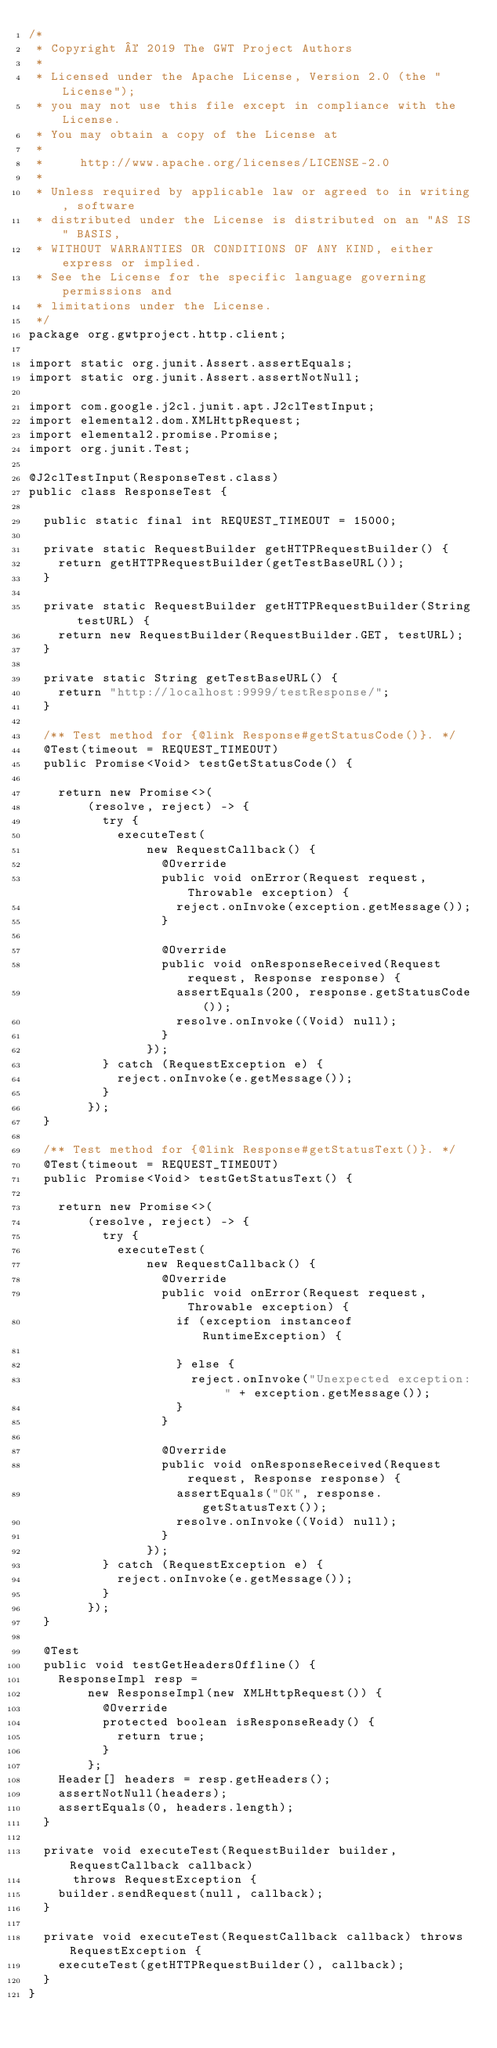<code> <loc_0><loc_0><loc_500><loc_500><_Java_>/*
 * Copyright © 2019 The GWT Project Authors
 *
 * Licensed under the Apache License, Version 2.0 (the "License");
 * you may not use this file except in compliance with the License.
 * You may obtain a copy of the License at
 *
 *     http://www.apache.org/licenses/LICENSE-2.0
 *
 * Unless required by applicable law or agreed to in writing, software
 * distributed under the License is distributed on an "AS IS" BASIS,
 * WITHOUT WARRANTIES OR CONDITIONS OF ANY KIND, either express or implied.
 * See the License for the specific language governing permissions and
 * limitations under the License.
 */
package org.gwtproject.http.client;

import static org.junit.Assert.assertEquals;
import static org.junit.Assert.assertNotNull;

import com.google.j2cl.junit.apt.J2clTestInput;
import elemental2.dom.XMLHttpRequest;
import elemental2.promise.Promise;
import org.junit.Test;

@J2clTestInput(ResponseTest.class)
public class ResponseTest {

  public static final int REQUEST_TIMEOUT = 15000;

  private static RequestBuilder getHTTPRequestBuilder() {
    return getHTTPRequestBuilder(getTestBaseURL());
  }

  private static RequestBuilder getHTTPRequestBuilder(String testURL) {
    return new RequestBuilder(RequestBuilder.GET, testURL);
  }

  private static String getTestBaseURL() {
    return "http://localhost:9999/testResponse/";
  }

  /** Test method for {@link Response#getStatusCode()}. */
  @Test(timeout = REQUEST_TIMEOUT)
  public Promise<Void> testGetStatusCode() {

    return new Promise<>(
        (resolve, reject) -> {
          try {
            executeTest(
                new RequestCallback() {
                  @Override
                  public void onError(Request request, Throwable exception) {
                    reject.onInvoke(exception.getMessage());
                  }

                  @Override
                  public void onResponseReceived(Request request, Response response) {
                    assertEquals(200, response.getStatusCode());
                    resolve.onInvoke((Void) null);
                  }
                });
          } catch (RequestException e) {
            reject.onInvoke(e.getMessage());
          }
        });
  }

  /** Test method for {@link Response#getStatusText()}. */
  @Test(timeout = REQUEST_TIMEOUT)
  public Promise<Void> testGetStatusText() {

    return new Promise<>(
        (resolve, reject) -> {
          try {
            executeTest(
                new RequestCallback() {
                  @Override
                  public void onError(Request request, Throwable exception) {
                    if (exception instanceof RuntimeException) {

                    } else {
                      reject.onInvoke("Unexpected exception: " + exception.getMessage());
                    }
                  }

                  @Override
                  public void onResponseReceived(Request request, Response response) {
                    assertEquals("OK", response.getStatusText());
                    resolve.onInvoke((Void) null);
                  }
                });
          } catch (RequestException e) {
            reject.onInvoke(e.getMessage());
          }
        });
  }

  @Test
  public void testGetHeadersOffline() {
    ResponseImpl resp =
        new ResponseImpl(new XMLHttpRequest()) {
          @Override
          protected boolean isResponseReady() {
            return true;
          }
        };
    Header[] headers = resp.getHeaders();
    assertNotNull(headers);
    assertEquals(0, headers.length);
  }

  private void executeTest(RequestBuilder builder, RequestCallback callback)
      throws RequestException {
    builder.sendRequest(null, callback);
  }

  private void executeTest(RequestCallback callback) throws RequestException {
    executeTest(getHTTPRequestBuilder(), callback);
  }
}
</code> 